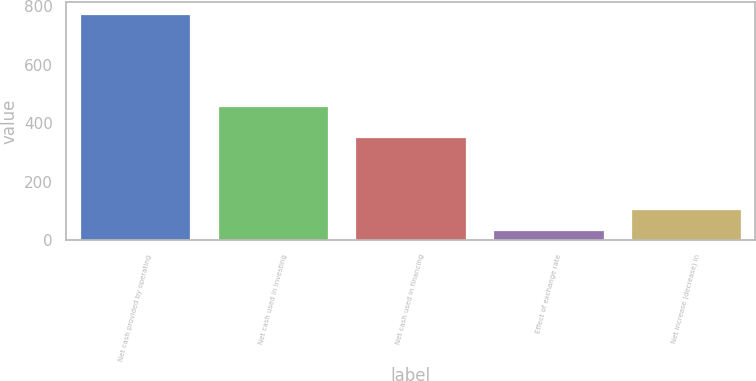Convert chart. <chart><loc_0><loc_0><loc_500><loc_500><bar_chart><fcel>Net cash provided by operating<fcel>Net cash used in investing<fcel>Net cash used in financing<fcel>Effect of exchange rate<fcel>Net increase (decrease) in<nl><fcel>774.2<fcel>458<fcel>352.1<fcel>34.4<fcel>108.38<nl></chart> 